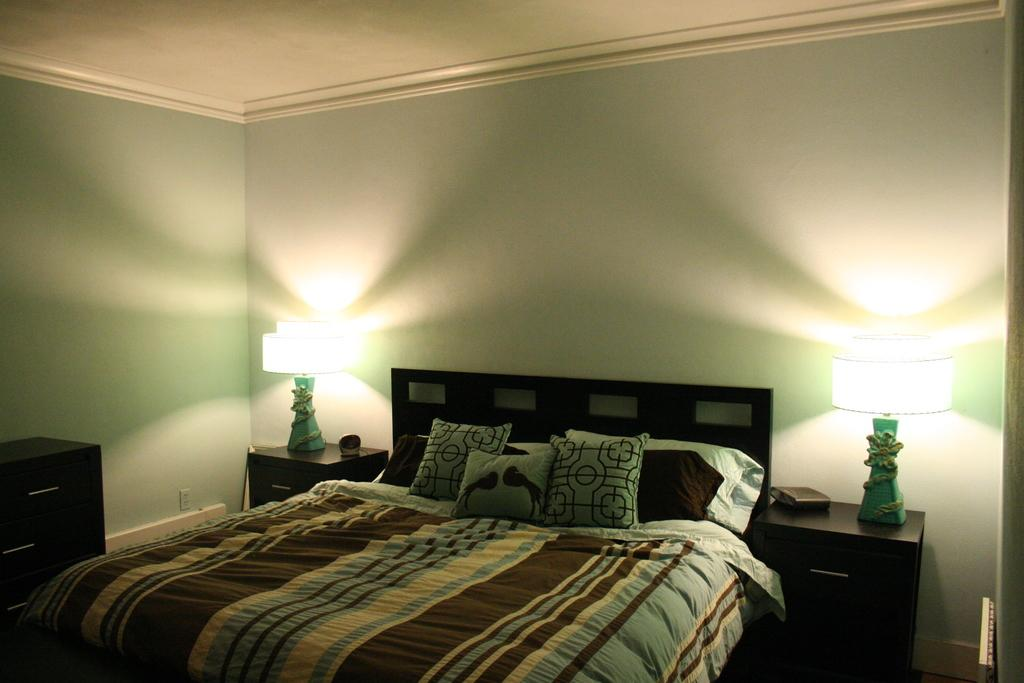What is the main piece of furniture in the center of the room? There is a bed in the center of the room. What is located on each side of the bed? There are two wooden tables, one on each side of the bed. What is placed on top of each table? There are two table lamps, one on each table. Where can the kettle be found in the room? There is no kettle present in the room; only a bed, two wooden tables, and two table lamps are visible. 